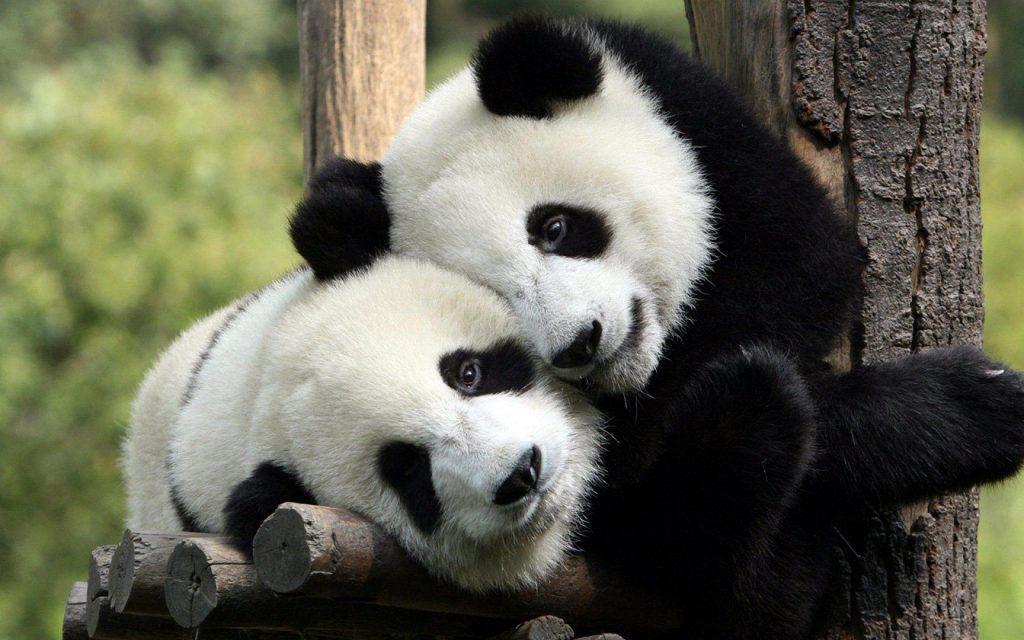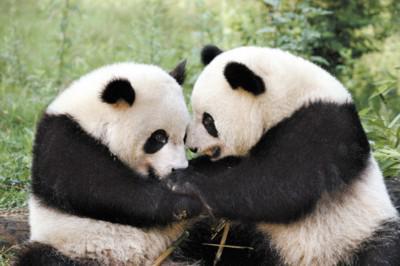The first image is the image on the left, the second image is the image on the right. Analyze the images presented: Is the assertion "The two pandas in the image on the left are eating bamboo shoots." valid? Answer yes or no. No. The first image is the image on the left, the second image is the image on the right. Examine the images to the left and right. Is the description "Two pandas are face-to-face, one with its front paws touching the other, in the right image." accurate? Answer yes or no. Yes. 